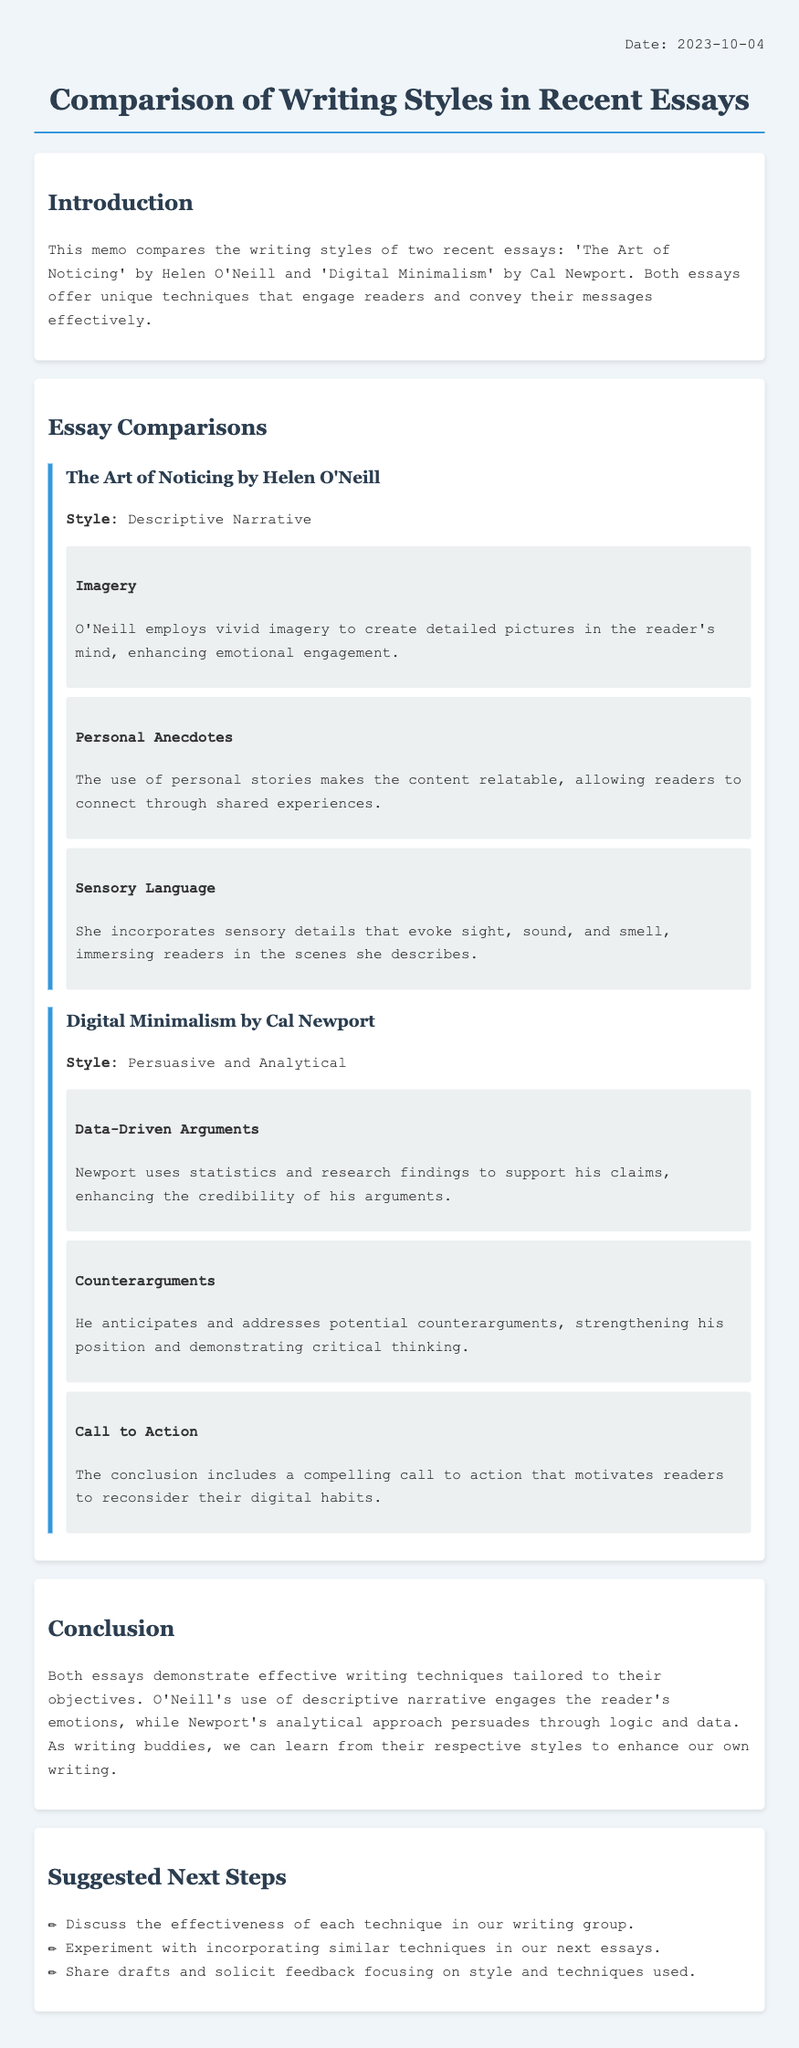What are the titles of the two essays compared? The titles are explicitly stated in the introduction section of the document, which mentions both essays.
Answer: The Art of Noticing, Digital Minimalism Who is the author of 'The Art of Noticing'? The document clearly identifies the author of the first essay in the essay comparisons section.
Answer: Helen O'Neill What writing style is used in 'Digital Minimalism'? The style is mentioned directly in the section dedicated to the second essay, indicating the approach taken by the author.
Answer: Persuasive and Analytical What technique involves using personal stories? This technique is specified under the first essay, providing insight into the author's method of engaging the audience.
Answer: Personal Anecdotes What is one key feature of Newport's writing style? The document lists specific techniques used by Newport, one of which highlights a crucial aspect of his persuasive style.
Answer: Data-Driven Arguments What type of conclusion does Newport's essay include? The description of Newport's techniques highlights the conclusion's impact on the audience, specifying its purpose.
Answer: Call to Action What is the date of the memo? The date is mentioned in the memo header at the top of the document.
Answer: 2023-10-04 What is one next step suggested for writing buddies? The recommended next steps are outlined in a bulleted list, detailing actions for improvement in writing.
Answer: Discuss the effectiveness of each technique in our writing group 